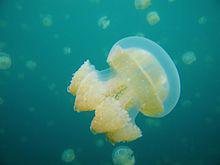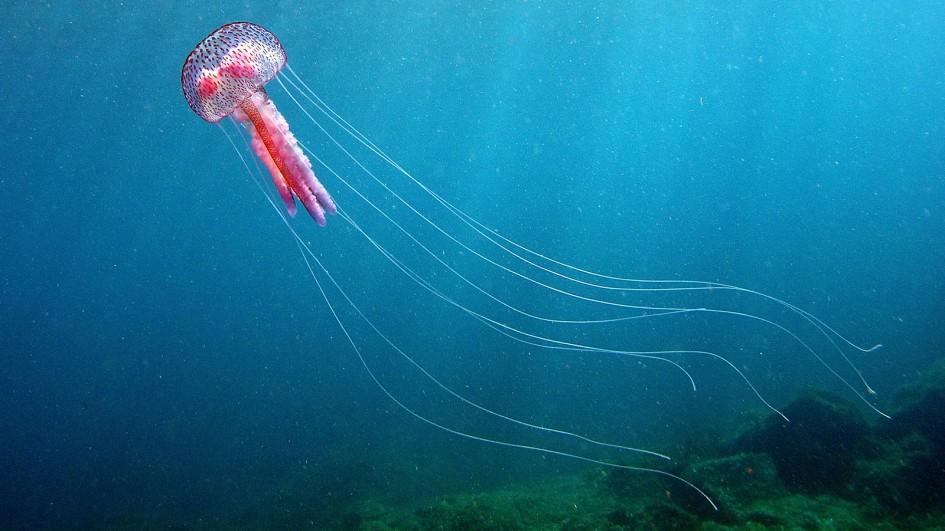The first image is the image on the left, the second image is the image on the right. Assess this claim about the two images: "The right image contains exactly one pink jellyfish.". Correct or not? Answer yes or no. Yes. The first image is the image on the left, the second image is the image on the right. For the images displayed, is the sentence "There is a red jellyfish on one of the iamges." factually correct? Answer yes or no. Yes. 